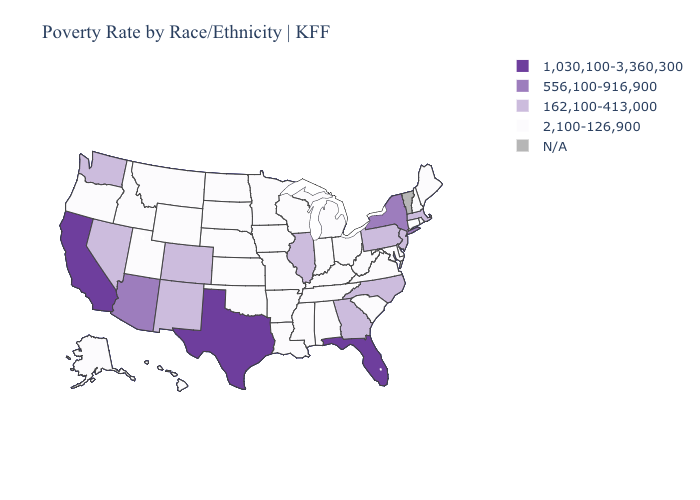Name the states that have a value in the range 1,030,100-3,360,300?
Keep it brief. California, Florida, Texas. What is the value of Colorado?
Concise answer only. 162,100-413,000. What is the lowest value in the Northeast?
Keep it brief. 2,100-126,900. What is the value of Utah?
Write a very short answer. 2,100-126,900. Name the states that have a value in the range N/A?
Short answer required. Vermont. Which states have the highest value in the USA?
Quick response, please. California, Florida, Texas. What is the value of North Dakota?
Short answer required. 2,100-126,900. Does Florida have the highest value in the South?
Concise answer only. Yes. What is the value of Missouri?
Write a very short answer. 2,100-126,900. Is the legend a continuous bar?
Quick response, please. No. What is the value of Oregon?
Give a very brief answer. 2,100-126,900. Does Iowa have the lowest value in the MidWest?
Keep it brief. Yes. What is the value of Colorado?
Be succinct. 162,100-413,000. Is the legend a continuous bar?
Short answer required. No. 